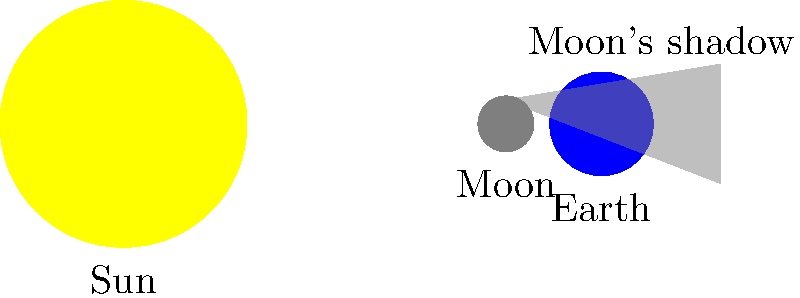What happens during a solar eclipse, as shown in the simple illustration? 1. The illustration shows three celestial bodies: the Sun, the Moon, and the Earth.

2. The Sun is the large yellow circle on the left side of the image.

3. The Earth is the blue circle on the right side of the image.

4. The Moon is the small gray circle between the Sun and the Earth.

5. During a solar eclipse:
   a. The Moon moves between the Sun and the Earth.
   b. The Moon casts a shadow on the Earth.

6. This shadow is represented by the gray triangle extending from the Moon to the Earth.

7. When the Moon's shadow falls on a part of the Earth, people in that area experience a solar eclipse.

8. During the eclipse, the Moon blocks some or all of the Sun's light from reaching that part of the Earth.

9. This causes the sky to darken temporarily, making it look like night during the day.
Answer: The Moon blocks the Sun's light from reaching Earth. 